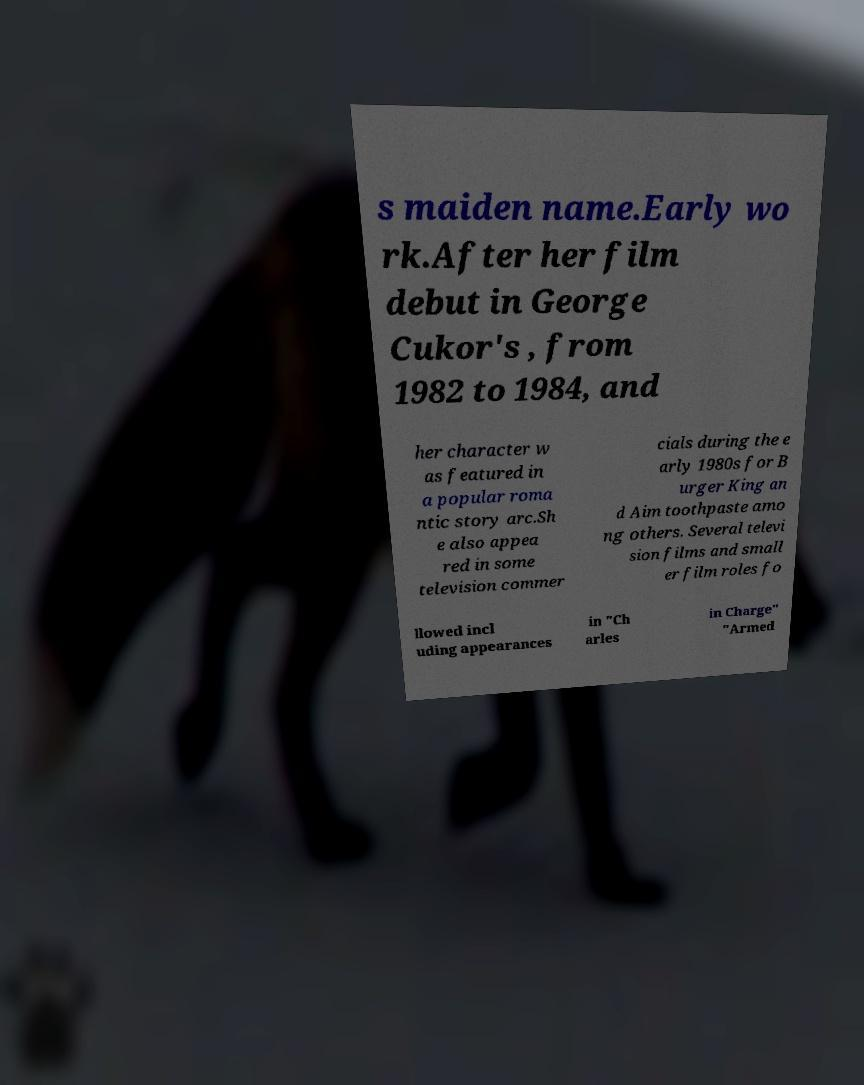Can you accurately transcribe the text from the provided image for me? s maiden name.Early wo rk.After her film debut in George Cukor's , from 1982 to 1984, and her character w as featured in a popular roma ntic story arc.Sh e also appea red in some television commer cials during the e arly 1980s for B urger King an d Aim toothpaste amo ng others. Several televi sion films and small er film roles fo llowed incl uding appearances in "Ch arles in Charge" "Armed 